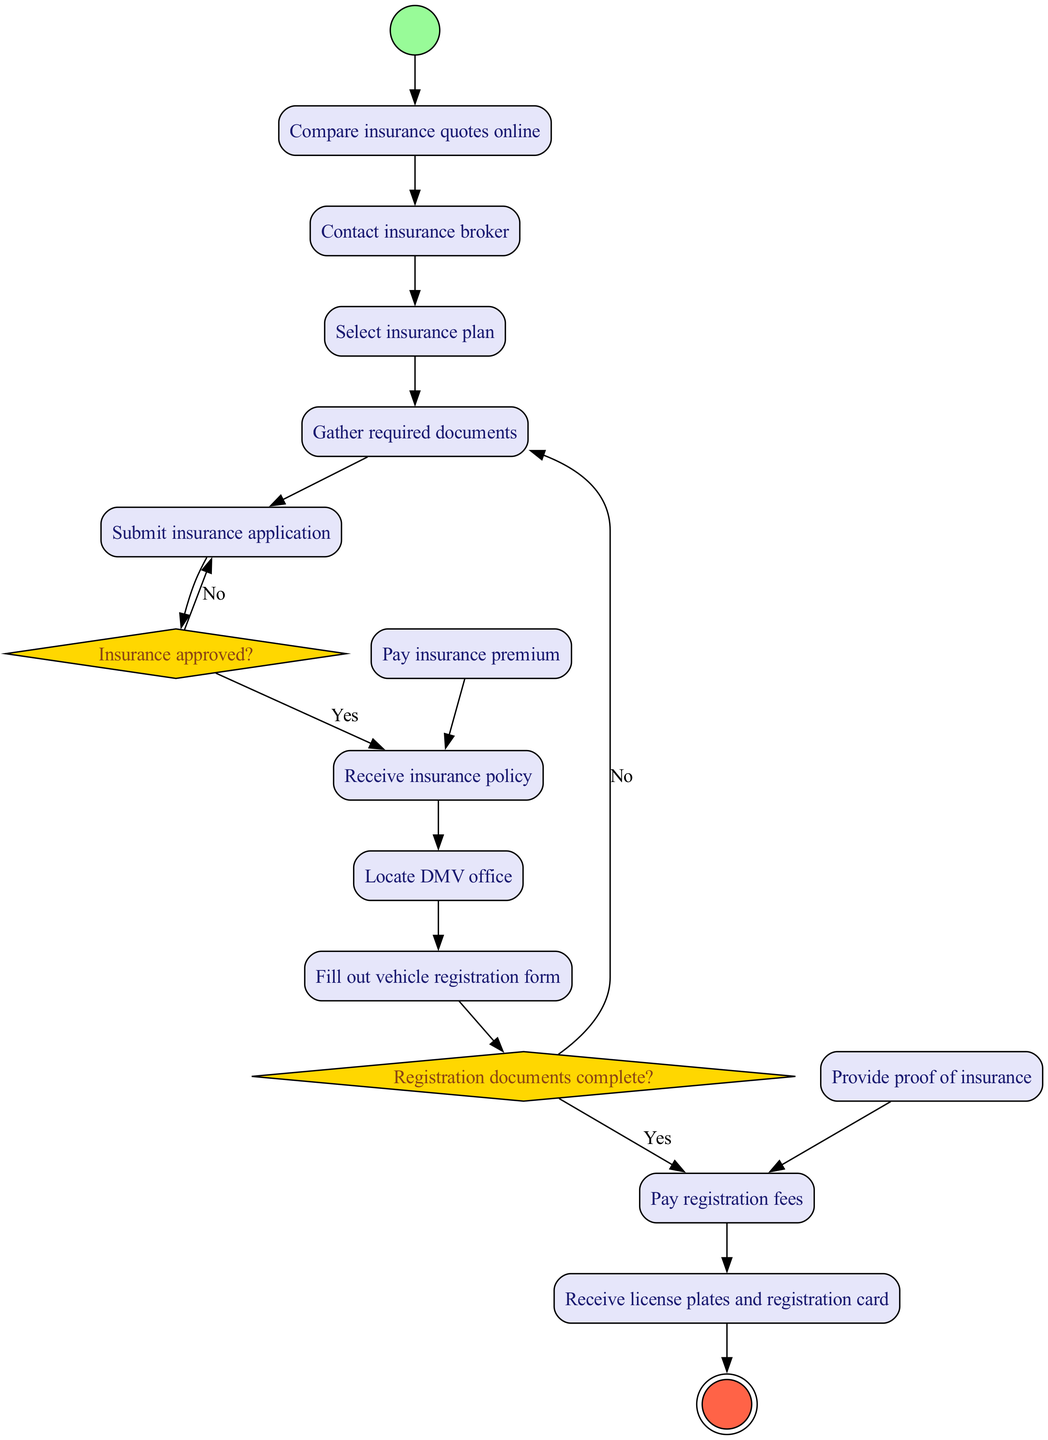What is the first activity in the workflow? The first activity is represented in the diagram as the starting point, which is "Research vehicle insurance options." This node is directly linked to the initial node indicating the start of the process.
Answer: Research vehicle insurance options How many activities are listed in the diagram? By counting the activities provided within the activities section, there are a total of 12 activities included in the workflow leading to the final outcome.
Answer: 12 What is the decision made after submitting the insurance application? The decision node indicates whether the insurance is approved, with paths leading to either "Receive insurance policy" or "Review and resubmit application" based on the approval status.
Answer: Insurance approved? What action is taken if the registration documents are complete? If the registration documents are complete, the next action is to "Pay registration fees," as indicated in the decision path related to the registration documents.
Answer: Pay registration fees Which activity occurs immediately after contacting the insurance broker? The activity that follows "Contact insurance broker" is "Select insurance plan," indicating the next step in the process after that interaction.
Answer: Select insurance plan What happens if the proof of insurance is not provided during vehicle registration? If the proof of insurance is missing, the workflow indicates that you must gather the missing documents before proceeding with the registration. This ensures all necessary documents are collected before payment.
Answer: Gather missing documents What is the final outcome of the workflow? The final node of the diagram, representing the completion of the entire process, signifies that both insurance and registration have been successfully obtained for the vehicle.
Answer: Vehicle insured and registered What color represents decision nodes in the diagram? The decision nodes are represented in the diagram by a yellow color, which differentiates them from other activity shapes.
Answer: Yellow Which two activities need to be completed before payment of insurance? Before payment can be made for insurance, "Submit insurance application" and receiving the insurance policy must occur. The payment is contingent upon the application process being completed and approved.
Answer: Submit insurance application, Receive insurance policy 